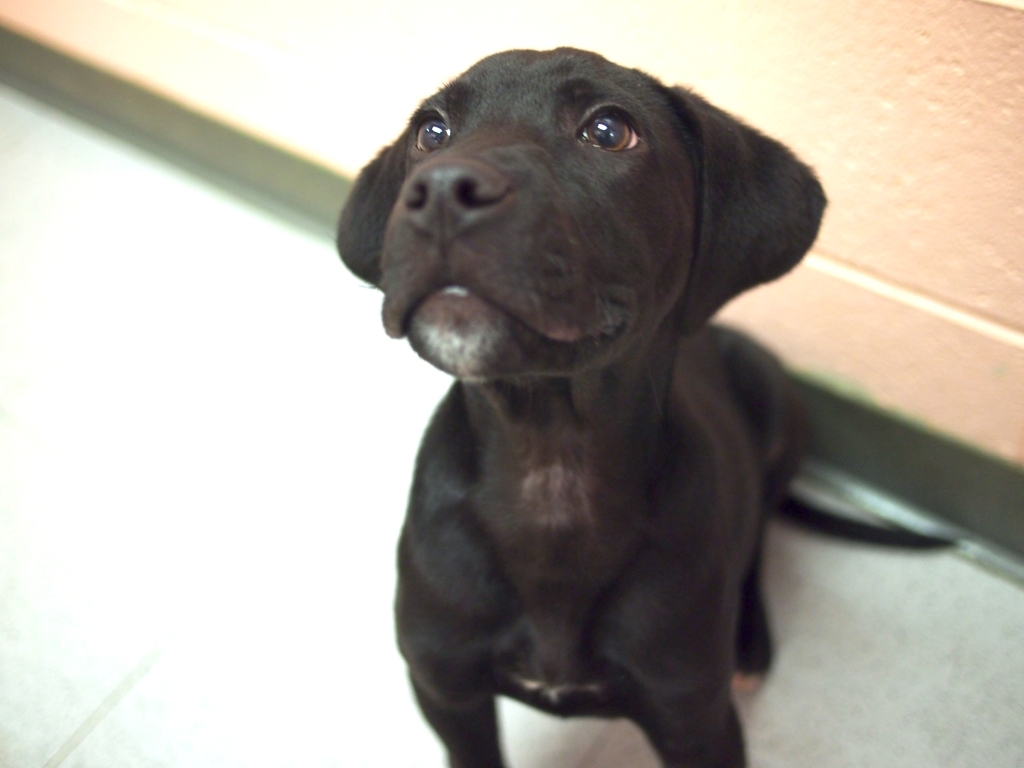Can you tell anything about the puppy's mood or temperament? The puppy appears to have a gentle and curious demeanor, indicated by its raised ears and attentive gaze. Its slight head tilt can also be a sign of interest and engagement with its environment. Does the puppy look well cared for? Yes, the puppy's coat looks clean and shiny, and there are no visible signs of distress or neglect. It seems to be in a good state of health and well-being. 